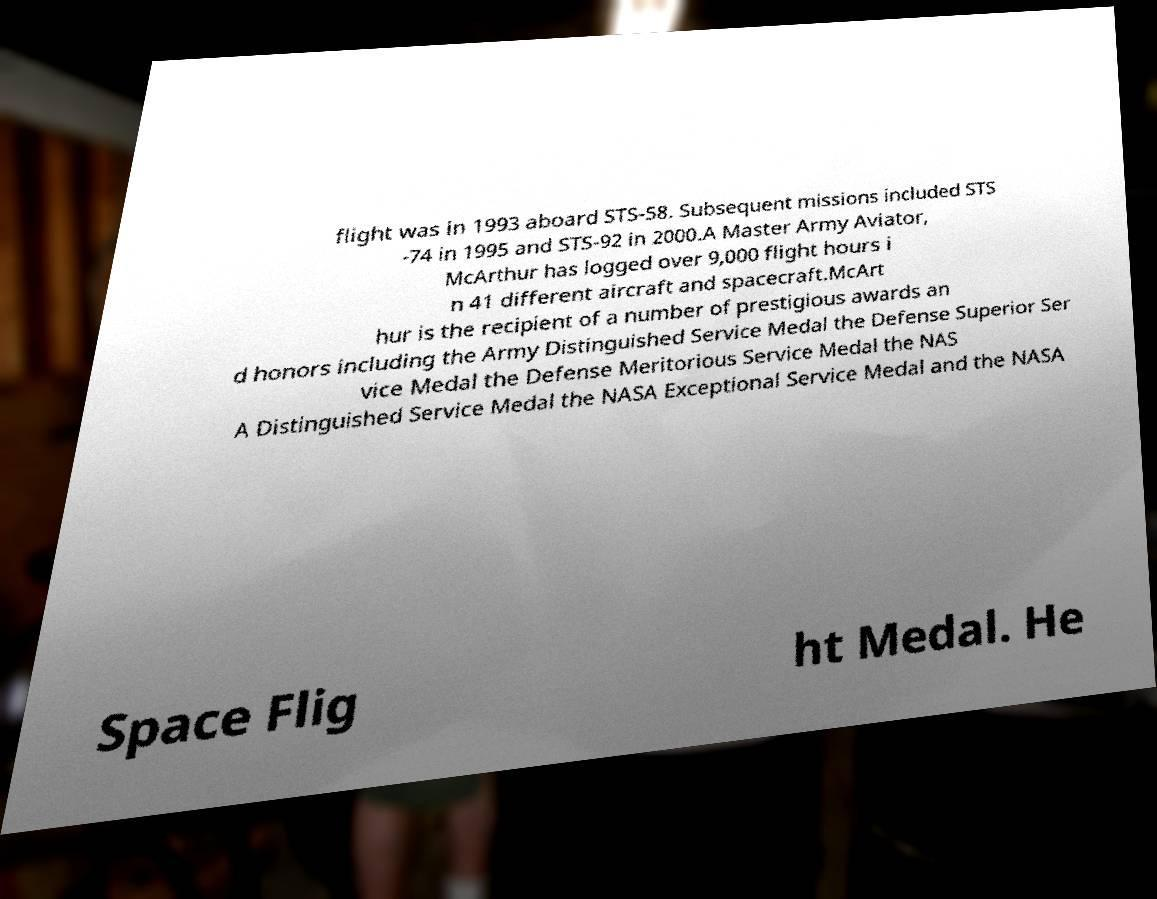Could you assist in decoding the text presented in this image and type it out clearly? flight was in 1993 aboard STS-58. Subsequent missions included STS -74 in 1995 and STS-92 in 2000.A Master Army Aviator, McArthur has logged over 9,000 flight hours i n 41 different aircraft and spacecraft.McArt hur is the recipient of a number of prestigious awards an d honors including the Army Distinguished Service Medal the Defense Superior Ser vice Medal the Defense Meritorious Service Medal the NAS A Distinguished Service Medal the NASA Exceptional Service Medal and the NASA Space Flig ht Medal. He 